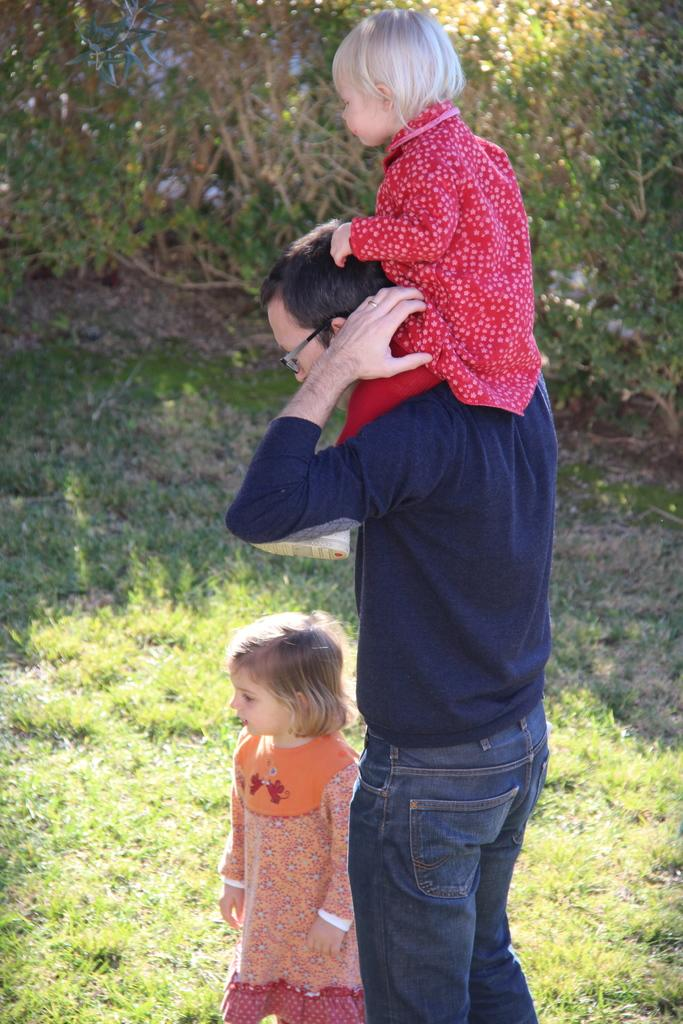Who is the main subject in the center of the image? There is a man in the center of the image. What is the man doing in the image? The man is holding a boy. Who else is present beside the man? There is a girl beside the man. What type of terrain is visible at the bottom of the image? There is grass at the bottom of the image. What can be seen in the background of the image? There are trees in the background of the image. What group is having a taste in the image? There is no group or taste mentioned in the image. 